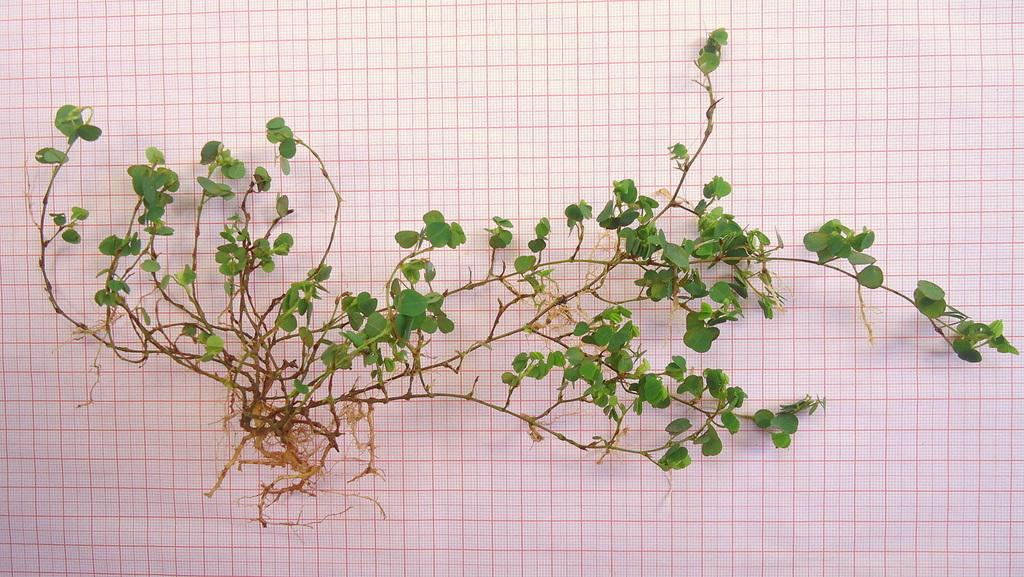What type of living organism is in the image? There is a plant present in the image. What colors can be seen on the plant? The plant has green and brown colors. What is the plant placed on in the image? The plant is placed on graph paper. Can you tell me how many sisters are touching the plant in the image? There are no people, including sisters, present in the image, and therefore no one is touching the plant. 